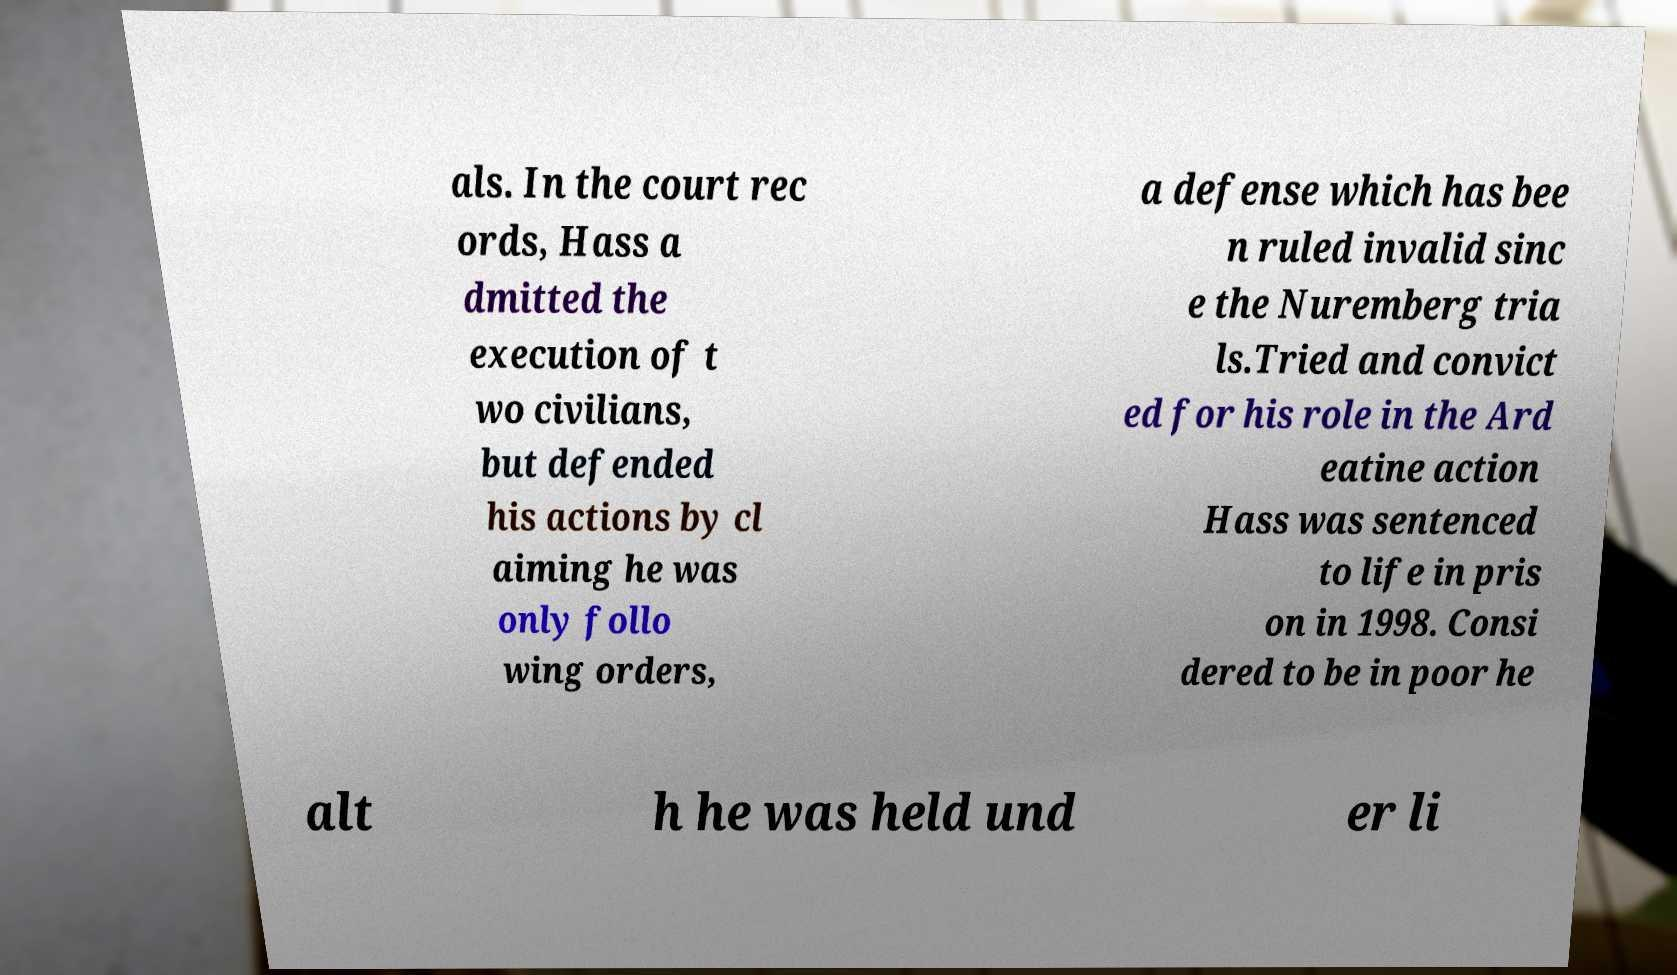Please identify and transcribe the text found in this image. als. In the court rec ords, Hass a dmitted the execution of t wo civilians, but defended his actions by cl aiming he was only follo wing orders, a defense which has bee n ruled invalid sinc e the Nuremberg tria ls.Tried and convict ed for his role in the Ard eatine action Hass was sentenced to life in pris on in 1998. Consi dered to be in poor he alt h he was held und er li 